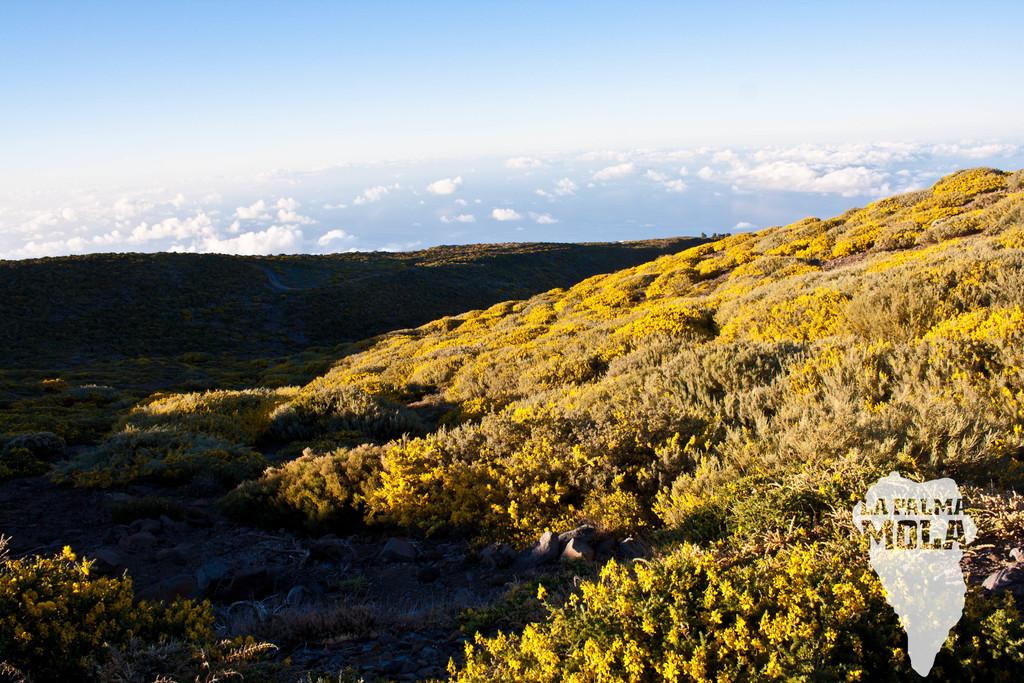What is the condition of the sky in the image? The sky in the image appears cloudy. What type of natural landform can be seen in the image? There are mountains visible in the image. What types of vegetation are present in the mountains? Bushes and plants are present in the mountains. What type of geological feature can be found in the mountains? Rocks are present in the mountains. Where is the camp located in the image? There is no camp present in the image. Can you see someone skateboarding on the rocks in the mountains? There is no skateboarding or skateboarder present in the image. 